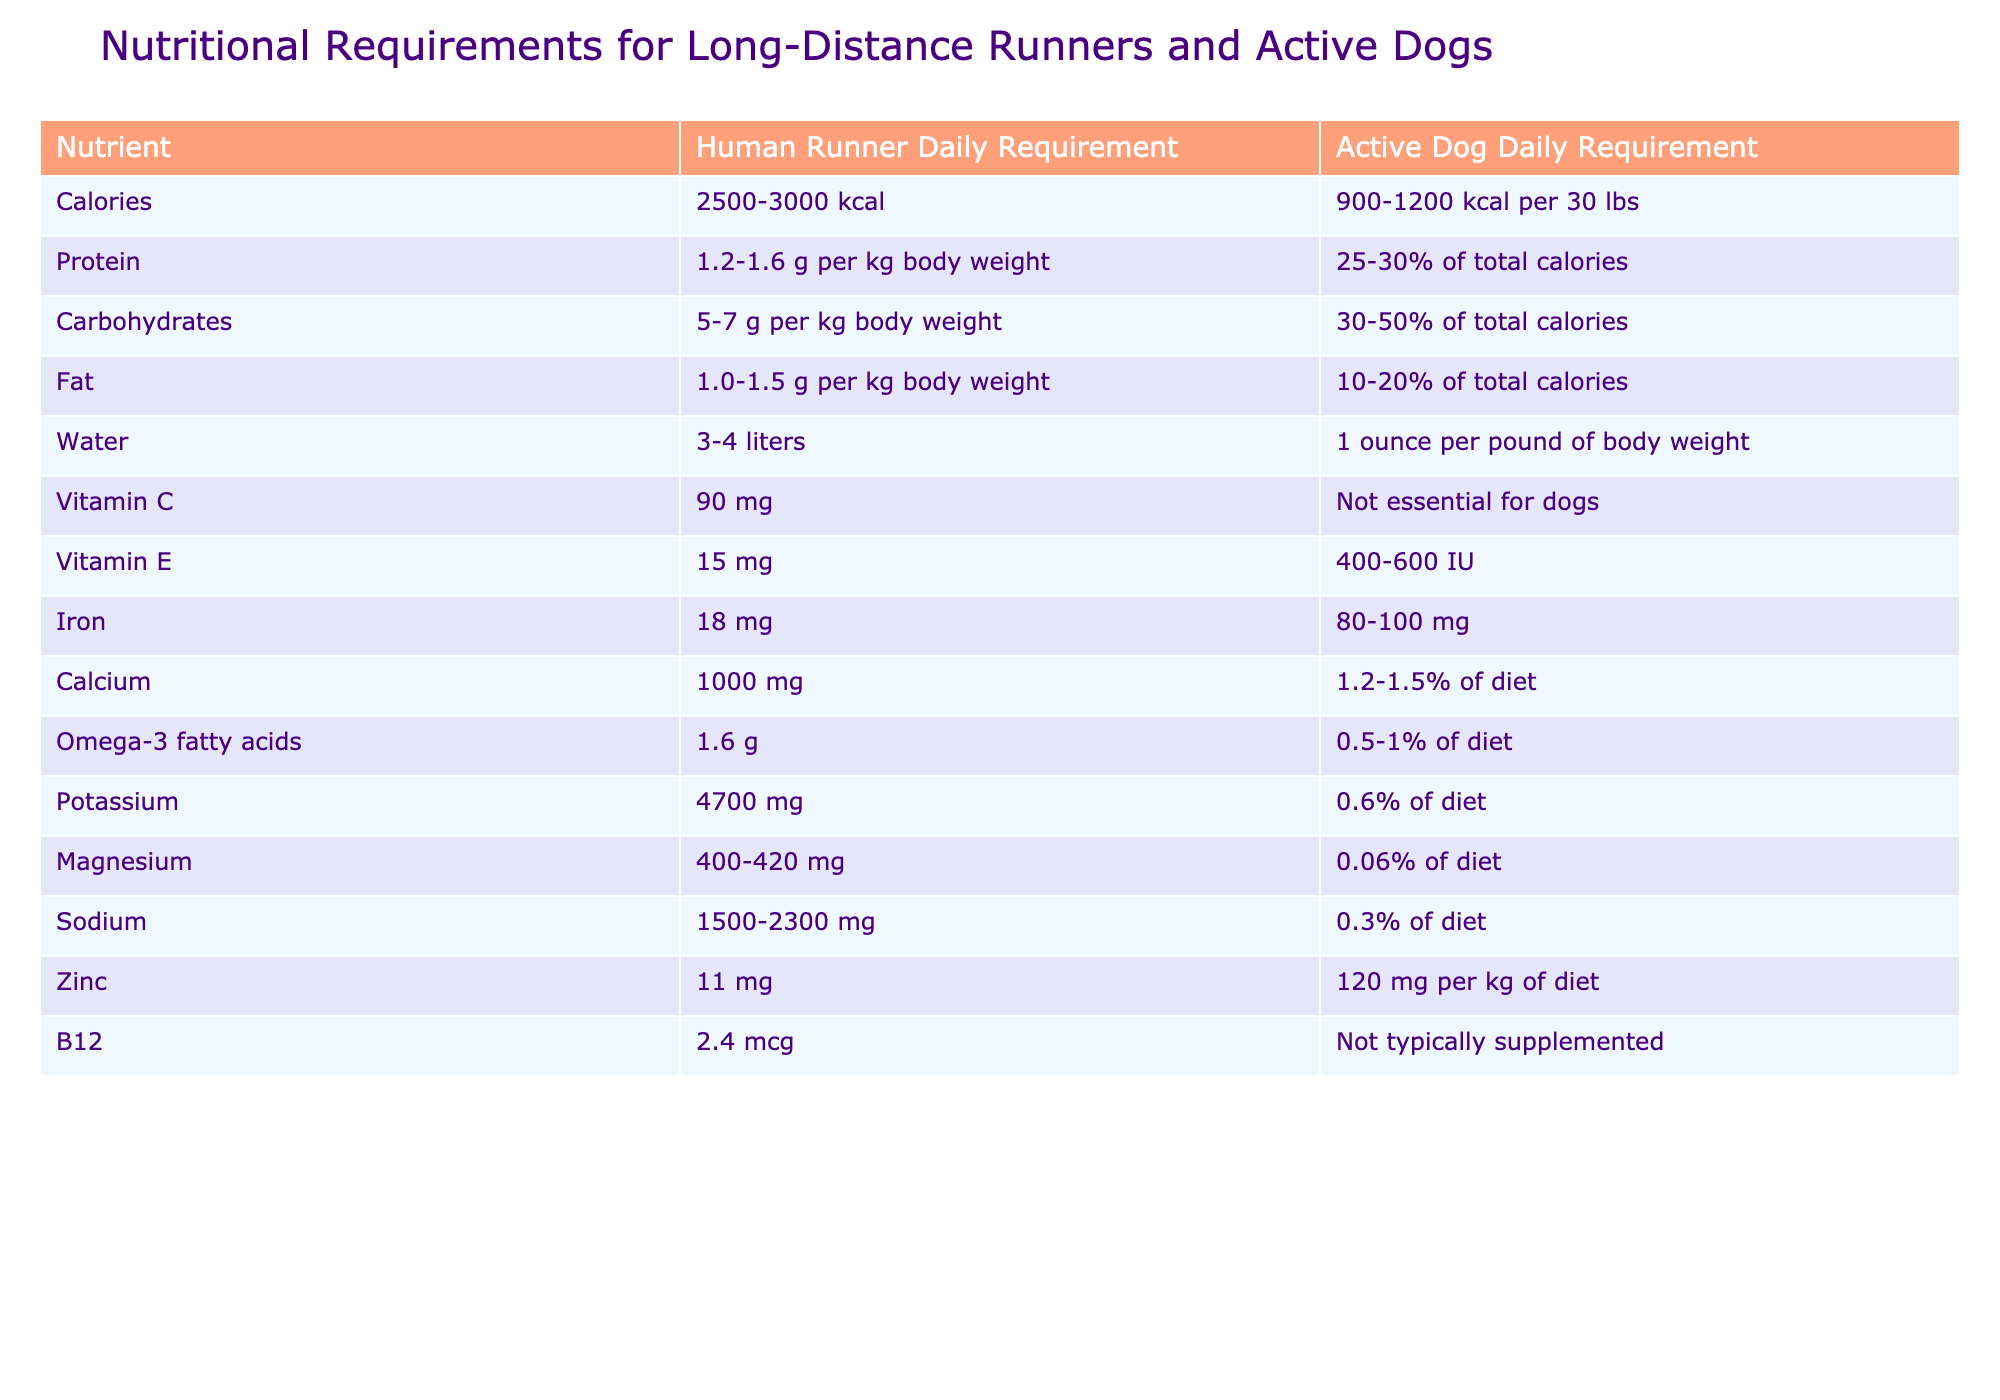What is the daily protein requirement for a human runner? The table states that the daily protein requirement for a human runner is between 1.2 to 1.6 grams per kilogram of body weight.
Answer: 1.2-1.6 g per kg body weight What is the daily fat requirement for an active dog weighing 30 lbs? An active dog weighing 30 lbs falls under the active dog daily requirement, which states that the fat should be 10-20% of total calories. Assuming a rough estimate of 1000 kcal for simplicity, the fat requirement would be 100-200 kcal from fat, which is approximately 11-22 g (since 1 g of fat = 9 kcal).
Answer: 10-20% of total calories How much Vitamin C do human runners need daily? The table indicates that human runners require 90 mg of Vitamin C daily.
Answer: 90 mg Is Vitamin E essential for dogs based on the table? No, the table states that Vitamin E is given to dogs in a range of 400-600 IU, but it does not specify it as essential.
Answer: No What is the difference in the daily calorie range between human runners and active dogs? The calorie range for human runners is 2500-3000 kcal, and for active dogs, it is 900-1200 kcal per 30 lbs. The difference can be calculated as follows: 2500 kcal - 1200 kcal = 1300 kcal and 3000 kcal - 900 kcal = 2100 kcal. Therefore, the difference in ranges is 1300-2100 kcal.
Answer: 1300-2100 kcal If a human runner weighs 70 kg, how many grams of carbohydrates do they need daily? The table indicates that a human runner requires 5-7 g of carbohydrates per kg body weight. For a 70 kg runner: 5 g/kg = 350 g and 7 g/kg = 490 g. The range is calculated as (70 kg) * (5 to 7 g) = 350 to 490 g of carbohydrates.
Answer: 350-490 g How many liters of water should an active dog drink if it weighs 50 lbs? The table states that an active dog requires 1 ounce of water per pound of body weight. A 50 lb dog would need 50 ounces, which is equivalent to 50/33.814 = 1.48 liters.
Answer: 1.48 liters What percentage of total calories should come from protein for an active dog? The table indicates that the protein requirement for an active dog is 25-30% of total calories.
Answer: 25-30% Is it true that dogs do not require B12 supplementation? The table states that B12 is not typically supplemented for dogs, indicating it is true that dogs do not require B12 supplementation.
Answer: True What is the average daily requirement of magnesium for a human runner? The table states that a human runner requires 400-420 mg of magnesium daily. To find the average, we calculate (400+420)/2 = 410 mg.
Answer: 410 mg 